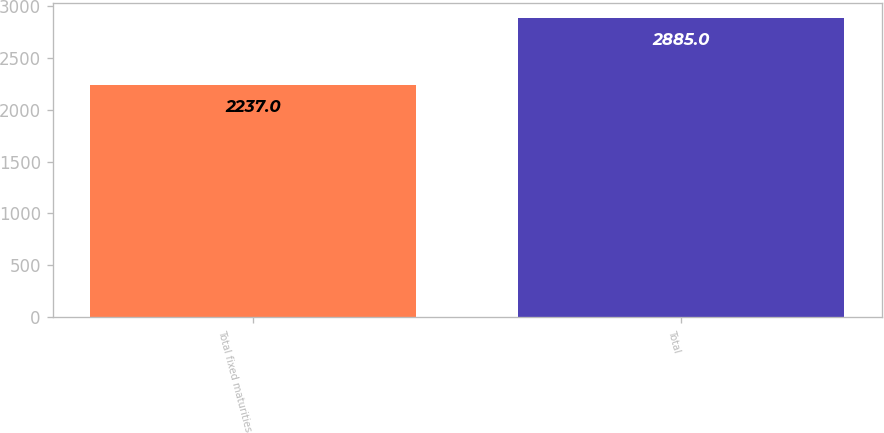<chart> <loc_0><loc_0><loc_500><loc_500><bar_chart><fcel>Total fixed maturities<fcel>Total<nl><fcel>2237<fcel>2885<nl></chart> 